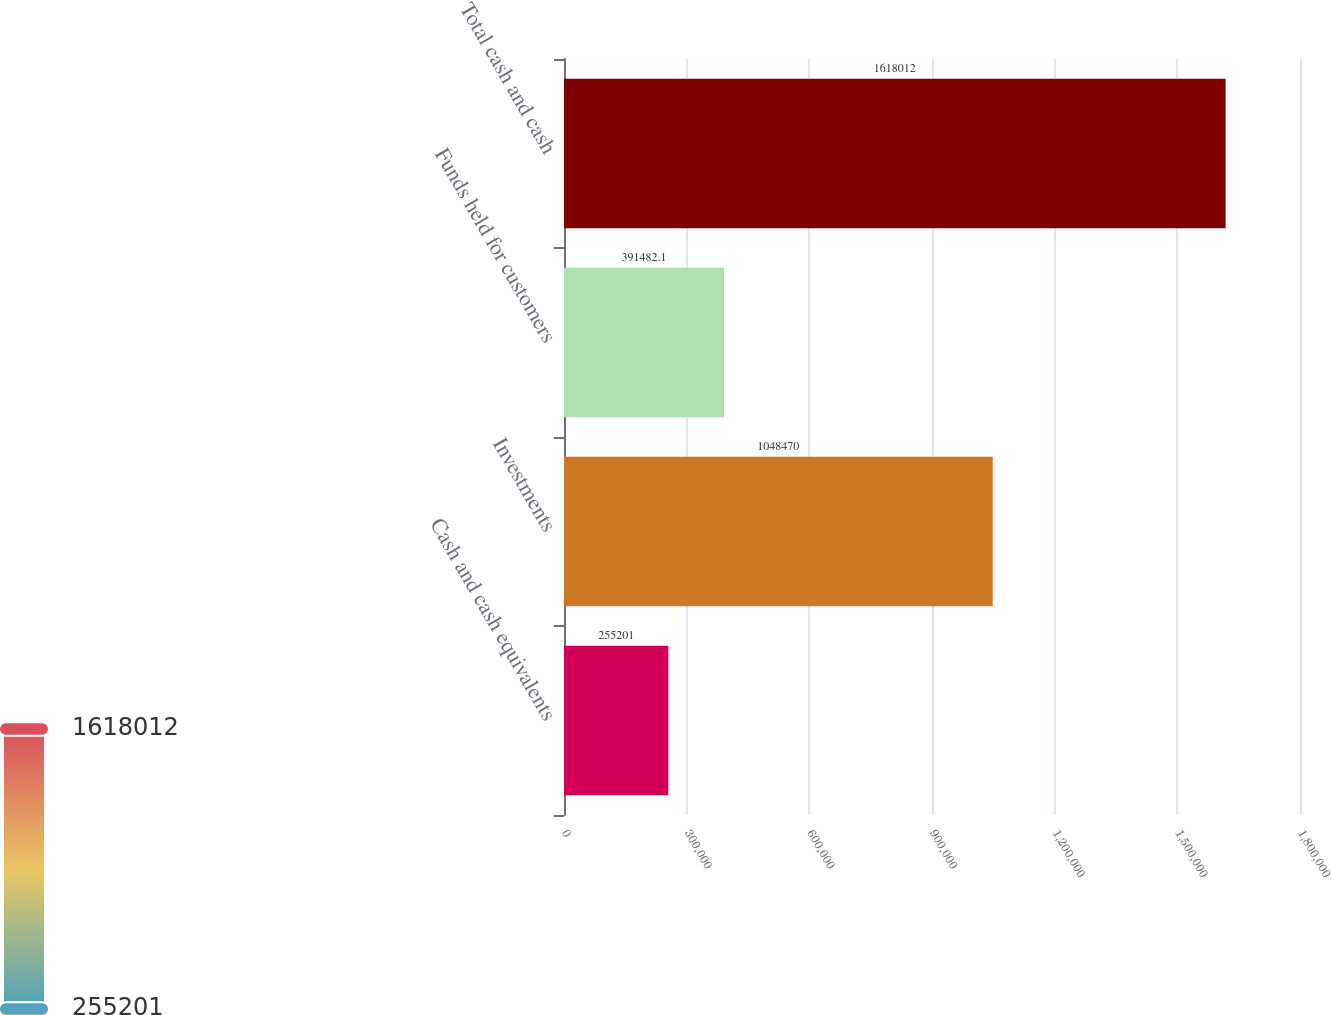Convert chart. <chart><loc_0><loc_0><loc_500><loc_500><bar_chart><fcel>Cash and cash equivalents<fcel>Investments<fcel>Funds held for customers<fcel>Total cash and cash<nl><fcel>255201<fcel>1.04847e+06<fcel>391482<fcel>1.61801e+06<nl></chart> 